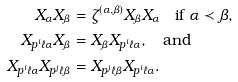Convert formula to latex. <formula><loc_0><loc_0><loc_500><loc_500>X _ { \alpha } X _ { \beta } & = \zeta ^ { ( \alpha , \beta ) } X _ { \beta } X _ { \alpha } \quad \text {if $\alpha \prec \beta$} , \\ X _ { p ^ { i } \ell \alpha } X _ { \beta } & = X _ { \beta } X _ { p ^ { i } \ell \alpha } , \quad \text {and} \\ X _ { p ^ { i } \ell \alpha } X _ { p ^ { j } \ell \beta } & = X _ { p ^ { j } \ell \beta } X _ { p ^ { i } \ell \alpha } .</formula> 